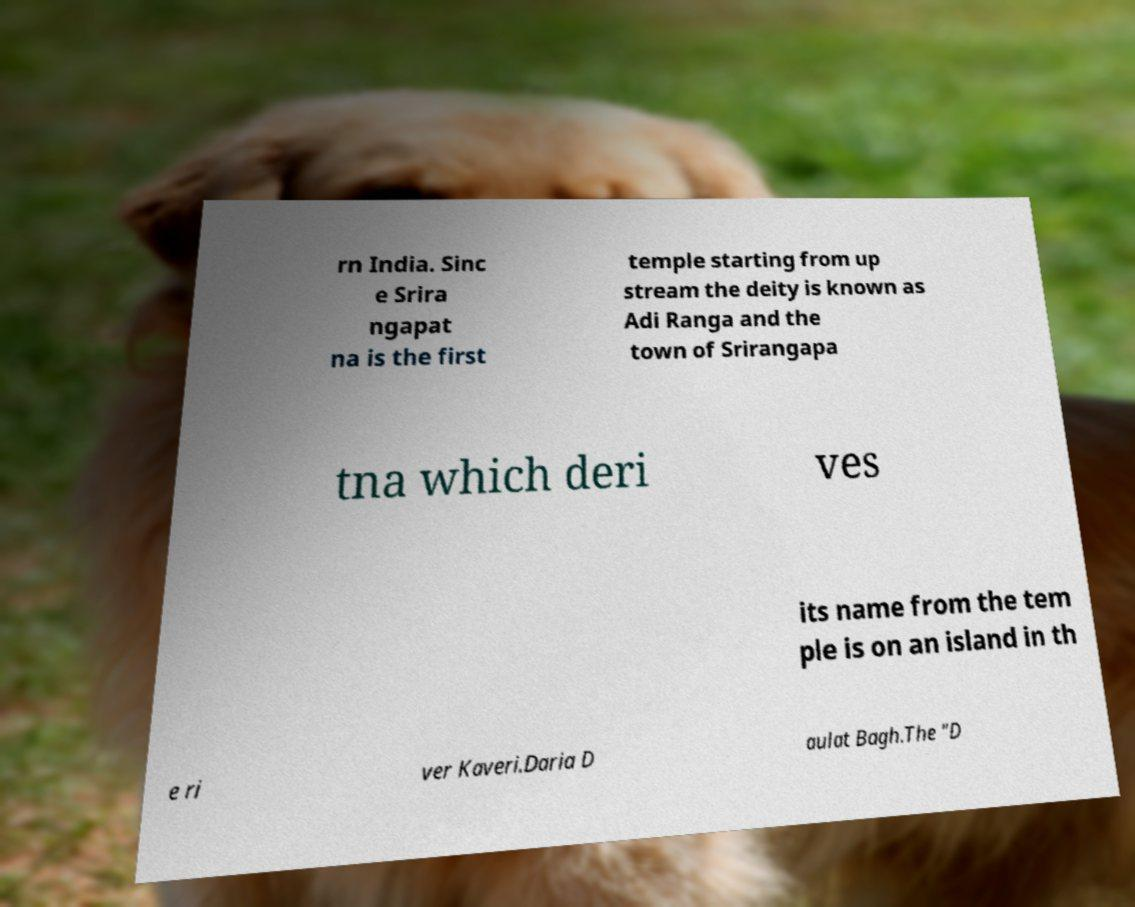For documentation purposes, I need the text within this image transcribed. Could you provide that? rn India. Sinc e Srira ngapat na is the first temple starting from up stream the deity is known as Adi Ranga and the town of Srirangapa tna which deri ves its name from the tem ple is on an island in th e ri ver Kaveri.Daria D aulat Bagh.The "D 